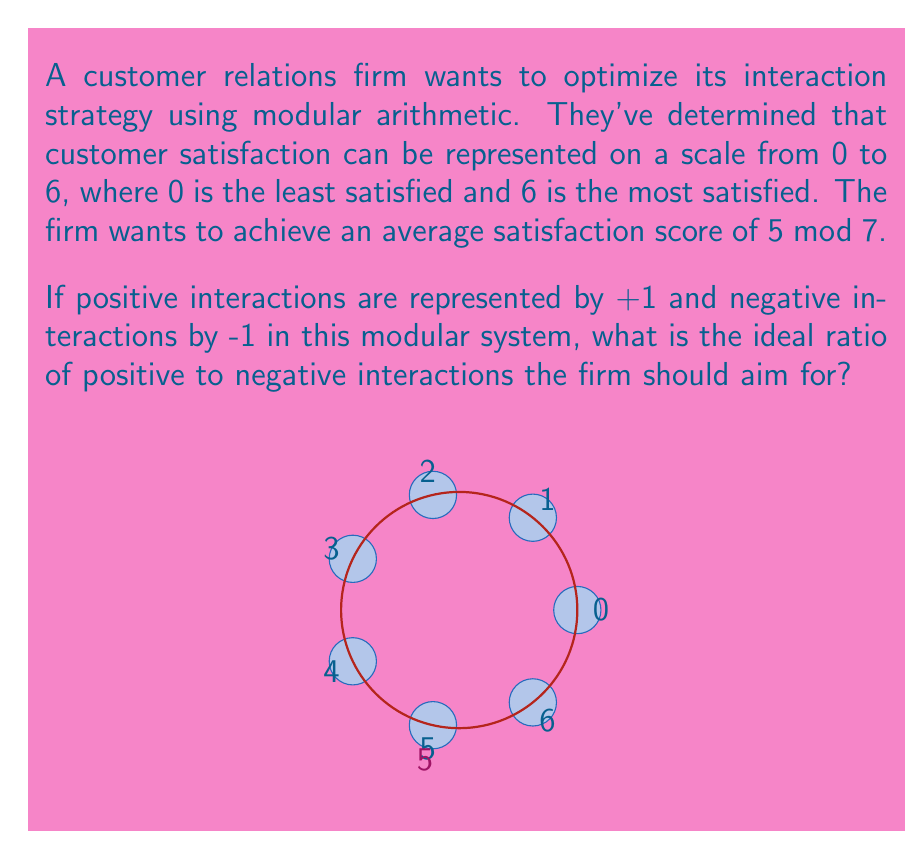Help me with this question. Let's approach this step-by-step:

1) In modular arithmetic mod 7, we have:
   $$(x \cdot (+1) + y \cdot (-1)) \equiv 5 \pmod{7}$$
   where $x$ is the number of positive interactions and $y$ is the number of negative interactions.

2) This can be simplified to:
   $$(x - y) \equiv 5 \pmod{7}$$

3) This means that $x - y$ should give a remainder of 5 when divided by 7.

4) The smallest positive solution for this is:
   $$x - y = 5$$

5) To find the ratio, we need to express this in terms of total interactions:
   Let $t = x + y$ (total interactions)
   Then $x = (t + 5)/2$ and $y = (t - 5)/2$

6) The ratio of positive to negative interactions is:
   $$\frac{x}{y} = \frac{(t + 5)/2}{(t - 5)/2} = \frac{t + 5}{t - 5}$$

7) As $t$ approaches infinity, this ratio approaches 1:1. However, for practical purposes, we can use the smallest integer solution:
   $$t = 7, x = 6, y = 1$$

8) This gives us a ratio of 6:1 positive to negative interactions.
Answer: 6:1 